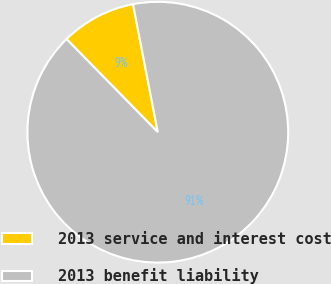<chart> <loc_0><loc_0><loc_500><loc_500><pie_chart><fcel>2013 service and interest cost<fcel>2013 benefit liability<nl><fcel>9.3%<fcel>90.7%<nl></chart> 